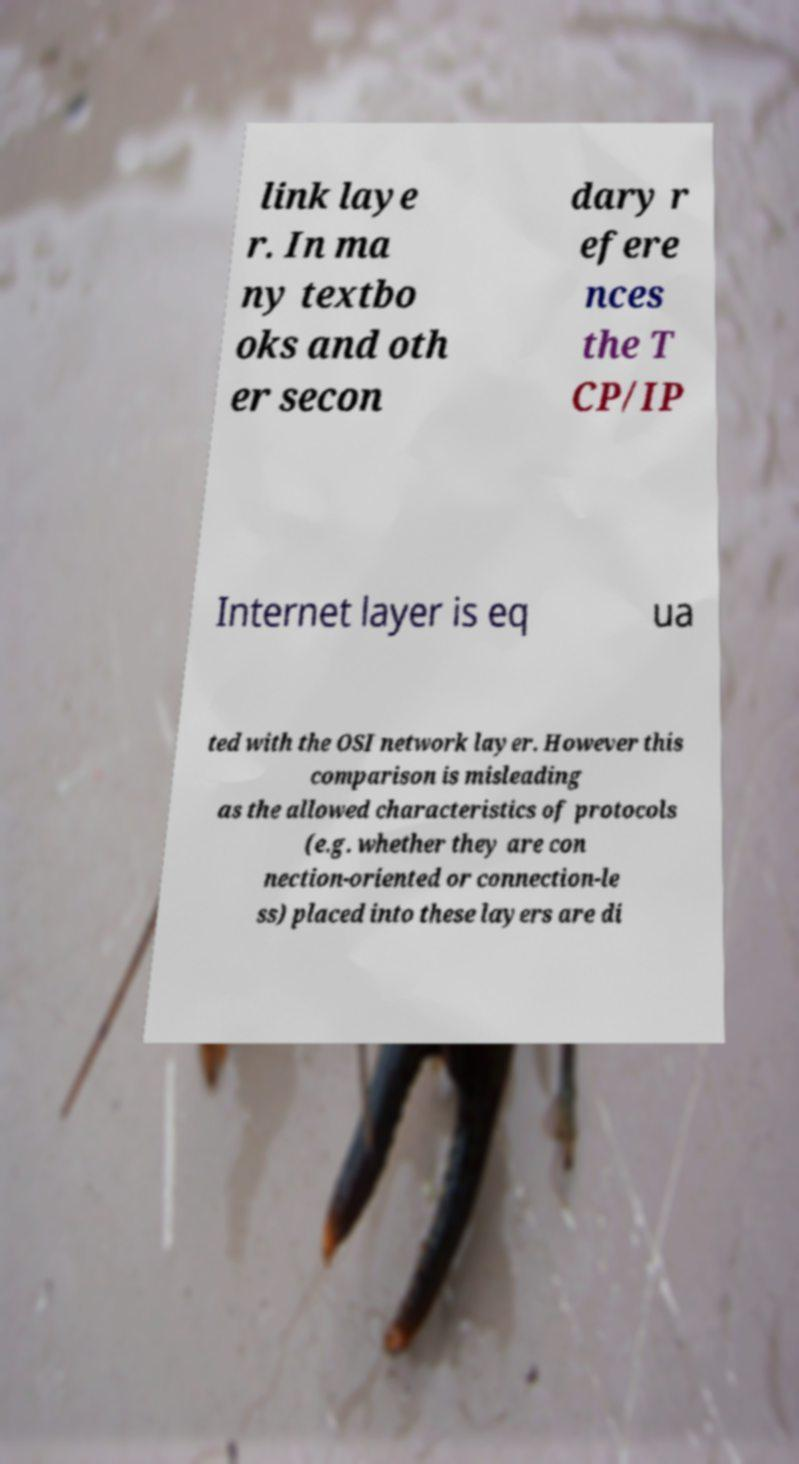Can you accurately transcribe the text from the provided image for me? link laye r. In ma ny textbo oks and oth er secon dary r efere nces the T CP/IP Internet layer is eq ua ted with the OSI network layer. However this comparison is misleading as the allowed characteristics of protocols (e.g. whether they are con nection-oriented or connection-le ss) placed into these layers are di 